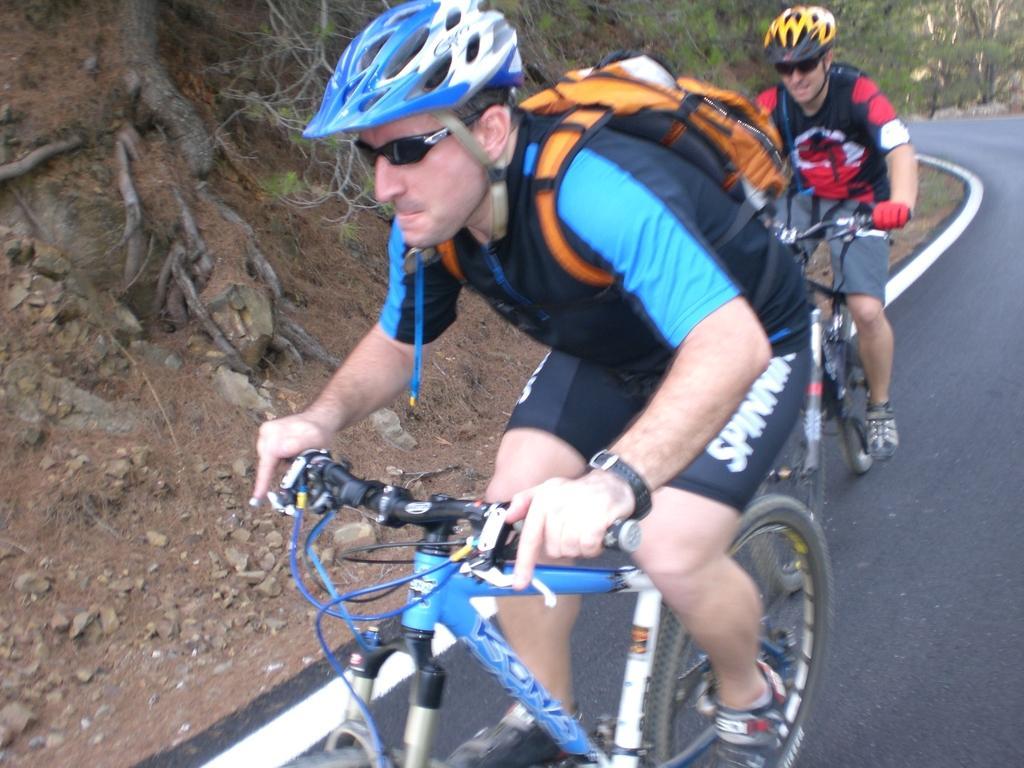Could you give a brief overview of what you see in this image? In this picture I can see the road in front, on which I can see 2 men who are on the cycles and I see that they're wearing helmets and carrying bags. In the background I can see the trees and I see number of stones. 